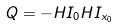<formula> <loc_0><loc_0><loc_500><loc_500>Q = - H I _ { 0 } H I _ { x _ { 0 } }</formula> 